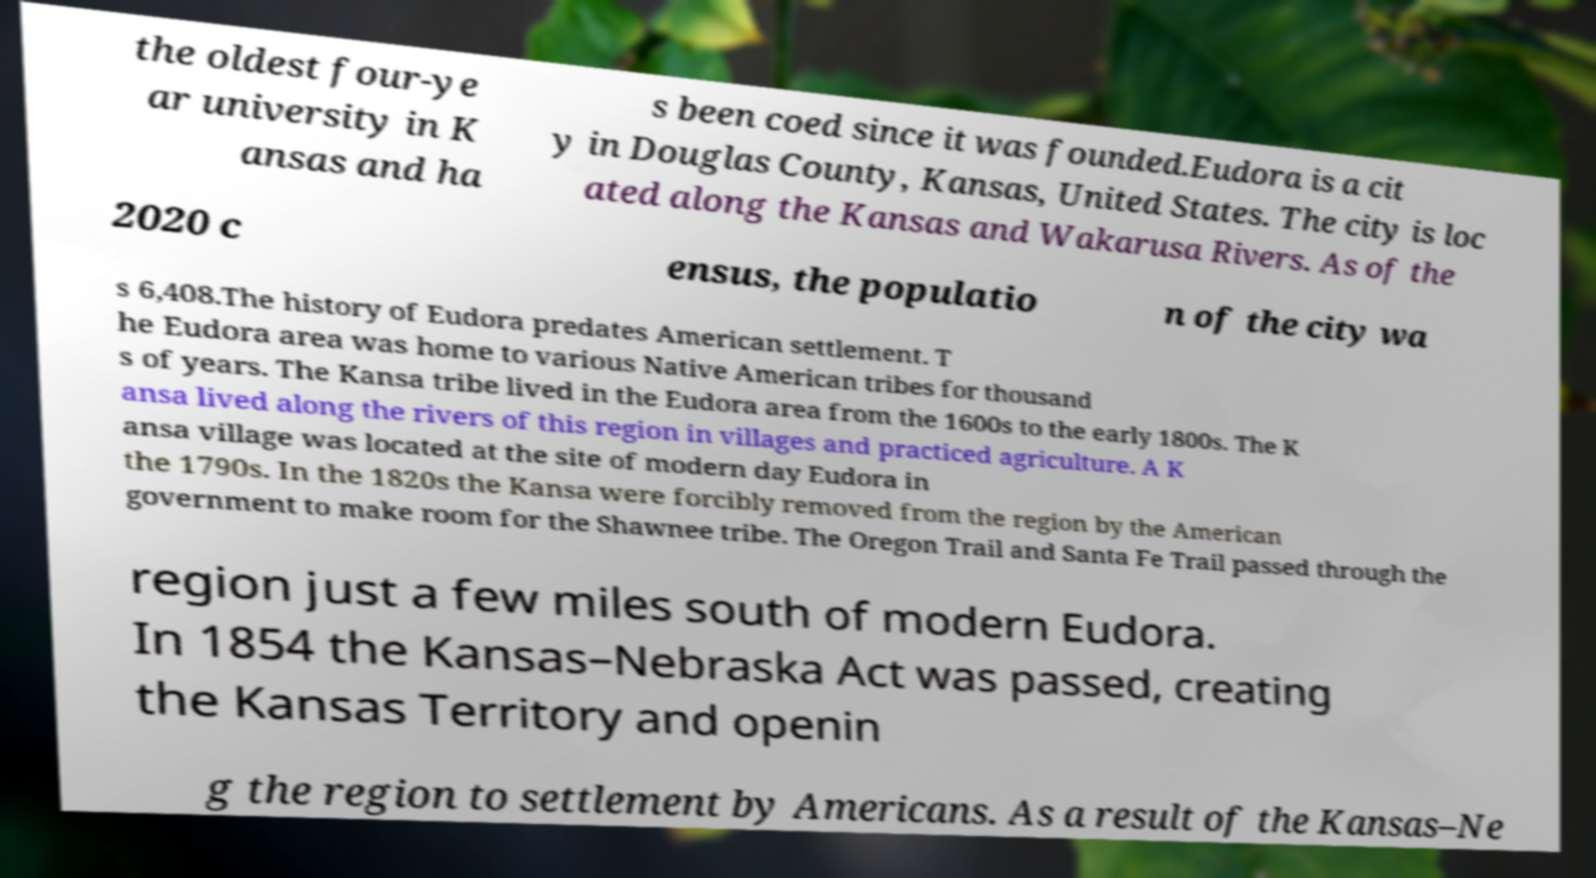I need the written content from this picture converted into text. Can you do that? the oldest four-ye ar university in K ansas and ha s been coed since it was founded.Eudora is a cit y in Douglas County, Kansas, United States. The city is loc ated along the Kansas and Wakarusa Rivers. As of the 2020 c ensus, the populatio n of the city wa s 6,408.The history of Eudora predates American settlement. T he Eudora area was home to various Native American tribes for thousand s of years. The Kansa tribe lived in the Eudora area from the 1600s to the early 1800s. The K ansa lived along the rivers of this region in villages and practiced agriculture. A K ansa village was located at the site of modern day Eudora in the 1790s. In the 1820s the Kansa were forcibly removed from the region by the American government to make room for the Shawnee tribe. The Oregon Trail and Santa Fe Trail passed through the region just a few miles south of modern Eudora. In 1854 the Kansas–Nebraska Act was passed, creating the Kansas Territory and openin g the region to settlement by Americans. As a result of the Kansas–Ne 